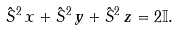Convert formula to latex. <formula><loc_0><loc_0><loc_500><loc_500>\hat { S } ^ { 2 } _ { \ } x + \hat { S } ^ { 2 } _ { \ } y + \hat { S } ^ { 2 } _ { \ } z = 2 \mathbb { I } .</formula> 